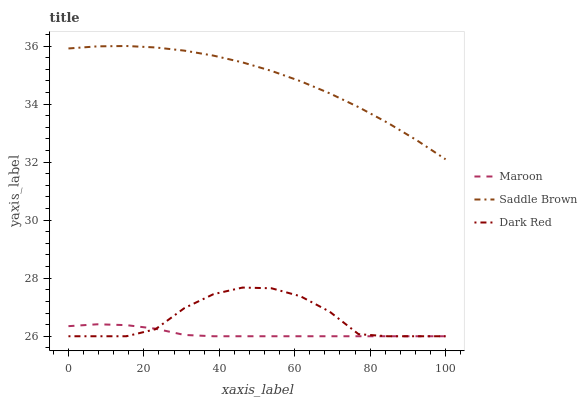Does Maroon have the minimum area under the curve?
Answer yes or no. Yes. Does Saddle Brown have the maximum area under the curve?
Answer yes or no. Yes. Does Saddle Brown have the minimum area under the curve?
Answer yes or no. No. Does Maroon have the maximum area under the curve?
Answer yes or no. No. Is Maroon the smoothest?
Answer yes or no. Yes. Is Dark Red the roughest?
Answer yes or no. Yes. Is Saddle Brown the smoothest?
Answer yes or no. No. Is Saddle Brown the roughest?
Answer yes or no. No. Does Dark Red have the lowest value?
Answer yes or no. Yes. Does Saddle Brown have the lowest value?
Answer yes or no. No. Does Saddle Brown have the highest value?
Answer yes or no. Yes. Does Maroon have the highest value?
Answer yes or no. No. Is Dark Red less than Saddle Brown?
Answer yes or no. Yes. Is Saddle Brown greater than Dark Red?
Answer yes or no. Yes. Does Dark Red intersect Maroon?
Answer yes or no. Yes. Is Dark Red less than Maroon?
Answer yes or no. No. Is Dark Red greater than Maroon?
Answer yes or no. No. Does Dark Red intersect Saddle Brown?
Answer yes or no. No. 